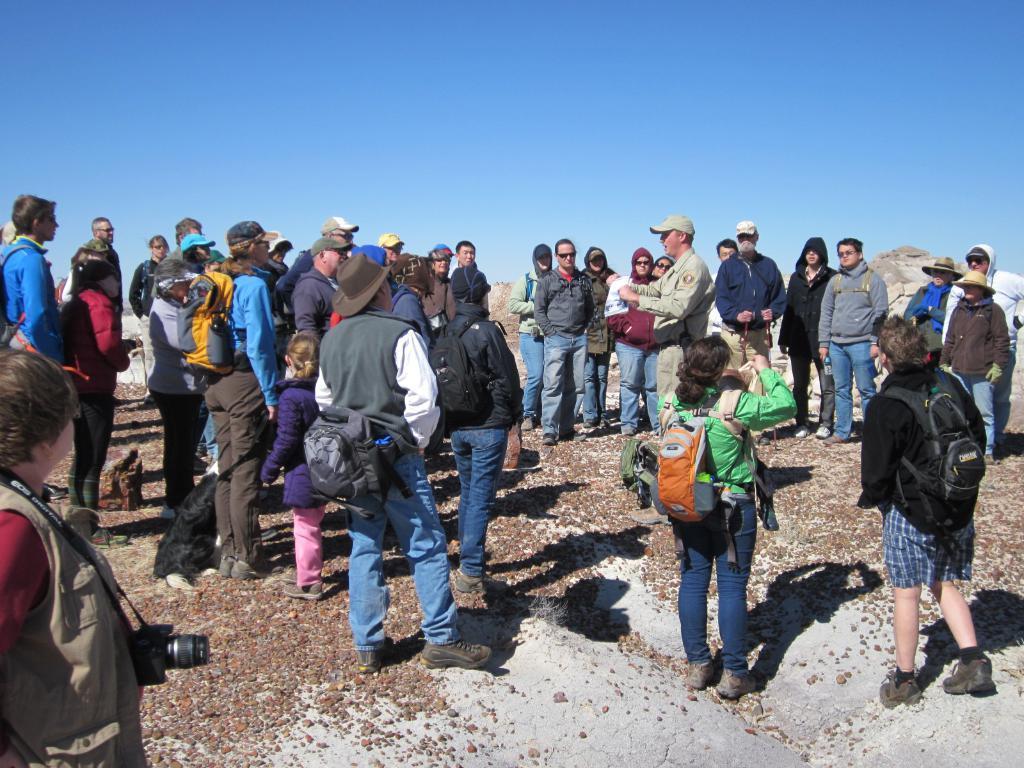In one or two sentences, can you explain what this image depicts? In this image I can see people standing. Few people are wearing caps and bags. There is sky at the top. 